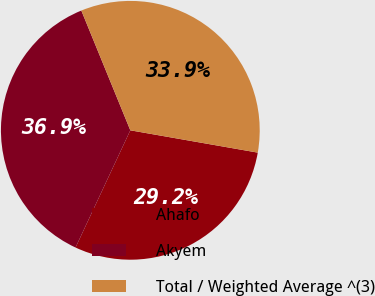Convert chart to OTSL. <chart><loc_0><loc_0><loc_500><loc_500><pie_chart><fcel>Ahafo<fcel>Akyem<fcel>Total / Weighted Average ^(3)<nl><fcel>29.2%<fcel>36.86%<fcel>33.94%<nl></chart> 